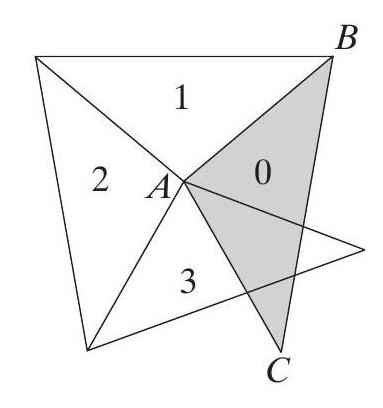We are going to make a spiral of isosceles triangles. We'll start with the shaded triangle $B A C$, which has a top angle $\angle B A C=100^{\circ}$, and move counterclockwise. Let $\triangle A B C$ have number 0. Every of the next triangles (with numbers 1, 2, $3, \ldots$ ) will have exactly one edge adjoining the previous one (see the picture). What will be the number of the first triangle which precisely covers triangle $\mathrm{nr}$. 0?
 Answer is 18. 